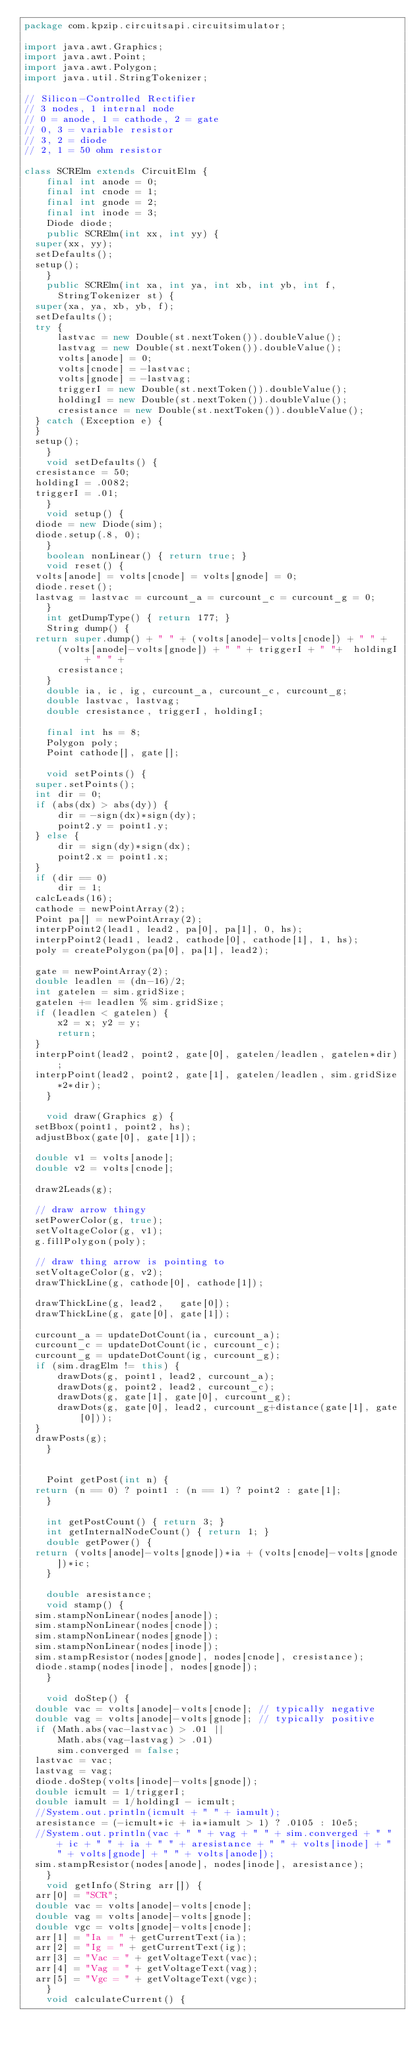<code> <loc_0><loc_0><loc_500><loc_500><_Java_>package com.kpzip.circuitsapi.circuitsimulator;

import java.awt.Graphics;
import java.awt.Point;
import java.awt.Polygon;
import java.util.StringTokenizer;

// Silicon-Controlled Rectifier
// 3 nodes, 1 internal node
// 0 = anode, 1 = cathode, 2 = gate
// 0, 3 = variable resistor
// 3, 2 = diode
// 2, 1 = 50 ohm resistor

class SCRElm extends CircuitElm {
    final int anode = 0;
    final int cnode = 1;
    final int gnode = 2;
    final int inode = 3;
    Diode diode;
    public SCRElm(int xx, int yy) {
	super(xx, yy);
	setDefaults();
	setup();
    }
    public SCRElm(int xa, int ya, int xb, int yb, int f,
		  StringTokenizer st) {
	super(xa, ya, xb, yb, f);
	setDefaults();
	try {
	    lastvac = new Double(st.nextToken()).doubleValue();
	    lastvag = new Double(st.nextToken()).doubleValue();
	    volts[anode] = 0;
	    volts[cnode] = -lastvac;
	    volts[gnode] = -lastvag;
	    triggerI = new Double(st.nextToken()).doubleValue();
	    holdingI = new Double(st.nextToken()).doubleValue();
	    cresistance = new Double(st.nextToken()).doubleValue();
	} catch (Exception e) {
	}
	setup();
    }
    void setDefaults() {
	cresistance = 50;
	holdingI = .0082;
	triggerI = .01;
    }
    void setup() {
	diode = new Diode(sim);
	diode.setup(.8, 0);
    }
    boolean nonLinear() { return true; }
    void reset() {
	volts[anode] = volts[cnode] = volts[gnode] = 0;
	diode.reset();
	lastvag = lastvac = curcount_a = curcount_c = curcount_g = 0;
    }
    int getDumpType() { return 177; }
    String dump() {
	return super.dump() + " " + (volts[anode]-volts[cnode]) + " " +
	    (volts[anode]-volts[gnode]) + " " + triggerI + " "+  holdingI + " " +
	    cresistance;
    }
    double ia, ic, ig, curcount_a, curcount_c, curcount_g;
    double lastvac, lastvag;
    double cresistance, triggerI, holdingI;

    final int hs = 8;
    Polygon poly;
    Point cathode[], gate[];
	
    void setPoints() {
	super.setPoints();
	int dir = 0;
	if (abs(dx) > abs(dy)) {
	    dir = -sign(dx)*sign(dy);
	    point2.y = point1.y;
	} else {
	    dir = sign(dy)*sign(dx);
	    point2.x = point1.x;
	}
	if (dir == 0)
	    dir = 1;
	calcLeads(16);
	cathode = newPointArray(2);
	Point pa[] = newPointArray(2);
	interpPoint2(lead1, lead2, pa[0], pa[1], 0, hs);
	interpPoint2(lead1, lead2, cathode[0], cathode[1], 1, hs);
	poly = createPolygon(pa[0], pa[1], lead2);

	gate = newPointArray(2);
	double leadlen = (dn-16)/2;
	int gatelen = sim.gridSize;
	gatelen += leadlen % sim.gridSize;
	if (leadlen < gatelen) {
	    x2 = x; y2 = y;
	    return;
	}
	interpPoint(lead2, point2, gate[0], gatelen/leadlen, gatelen*dir);
	interpPoint(lead2, point2, gate[1], gatelen/leadlen, sim.gridSize*2*dir);
    }
	
    void draw(Graphics g) {
	setBbox(point1, point2, hs);
	adjustBbox(gate[0], gate[1]);

	double v1 = volts[anode];
	double v2 = volts[cnode];

	draw2Leads(g);

	// draw arrow thingy
	setPowerColor(g, true);
	setVoltageColor(g, v1);
	g.fillPolygon(poly);

	// draw thing arrow is pointing to
	setVoltageColor(g, v2);
	drawThickLine(g, cathode[0], cathode[1]);

	drawThickLine(g, lead2,   gate[0]);
	drawThickLine(g, gate[0], gate[1]);
	
	curcount_a = updateDotCount(ia, curcount_a);
	curcount_c = updateDotCount(ic, curcount_c);
	curcount_g = updateDotCount(ig, curcount_g);
	if (sim.dragElm != this) {
	    drawDots(g, point1, lead2, curcount_a);
	    drawDots(g, point2, lead2, curcount_c);
	    drawDots(g, gate[1], gate[0], curcount_g);
	    drawDots(g, gate[0], lead2, curcount_g+distance(gate[1], gate[0]));
	}
	drawPosts(g);
    }
	
    
    Point getPost(int n) {
	return (n == 0) ? point1 : (n == 1) ? point2 : gate[1];
    }
	
    int getPostCount() { return 3; }
    int getInternalNodeCount() { return 1; }
    double getPower() {
	return (volts[anode]-volts[gnode])*ia + (volts[cnode]-volts[gnode])*ic;
    }

    double aresistance;
    void stamp() {
	sim.stampNonLinear(nodes[anode]);
	sim.stampNonLinear(nodes[cnode]);
	sim.stampNonLinear(nodes[gnode]);
	sim.stampNonLinear(nodes[inode]);
	sim.stampResistor(nodes[gnode], nodes[cnode], cresistance);
	diode.stamp(nodes[inode], nodes[gnode]);
    }

    void doStep() {
	double vac = volts[anode]-volts[cnode]; // typically negative
	double vag = volts[anode]-volts[gnode]; // typically positive
	if (Math.abs(vac-lastvac) > .01 ||
	    Math.abs(vag-lastvag) > .01)
	    sim.converged = false;
	lastvac = vac;
	lastvag = vag;
	diode.doStep(volts[inode]-volts[gnode]);
	double icmult = 1/triggerI;
	double iamult = 1/holdingI - icmult;
	//System.out.println(icmult + " " + iamult);
	aresistance = (-icmult*ic + ia*iamult > 1) ? .0105 : 10e5;
	//System.out.println(vac + " " + vag + " " + sim.converged + " " + ic + " " + ia + " " + aresistance + " " + volts[inode] + " " + volts[gnode] + " " + volts[anode]);
	sim.stampResistor(nodes[anode], nodes[inode], aresistance);
    }
    void getInfo(String arr[]) {
	arr[0] = "SCR";
	double vac = volts[anode]-volts[cnode];
	double vag = volts[anode]-volts[gnode];
	double vgc = volts[gnode]-volts[cnode];
	arr[1] = "Ia = " + getCurrentText(ia);
	arr[2] = "Ig = " + getCurrentText(ig);
	arr[3] = "Vac = " + getVoltageText(vac);
	arr[4] = "Vag = " + getVoltageText(vag);
	arr[5] = "Vgc = " + getVoltageText(vgc);
    }
    void calculateCurrent() {</code> 